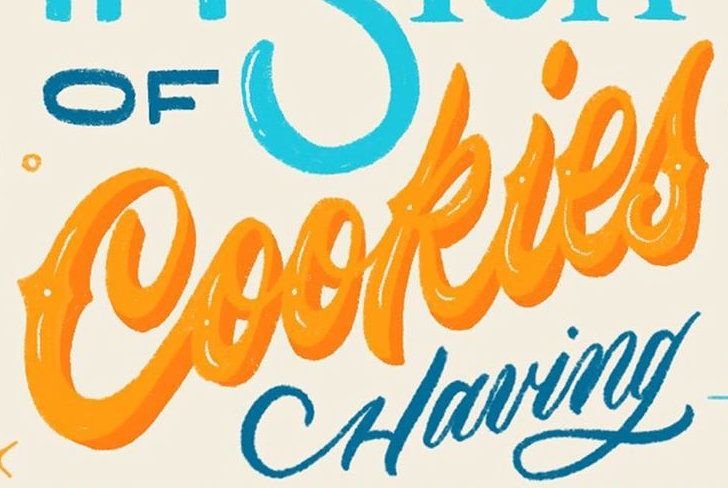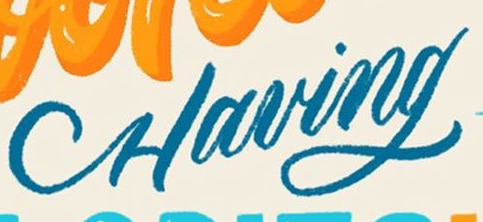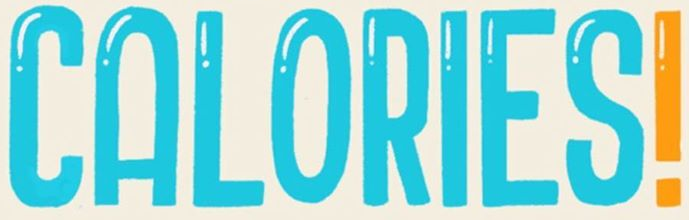Read the text content from these images in order, separated by a semicolon. Cookies; Having; CALORIES! 